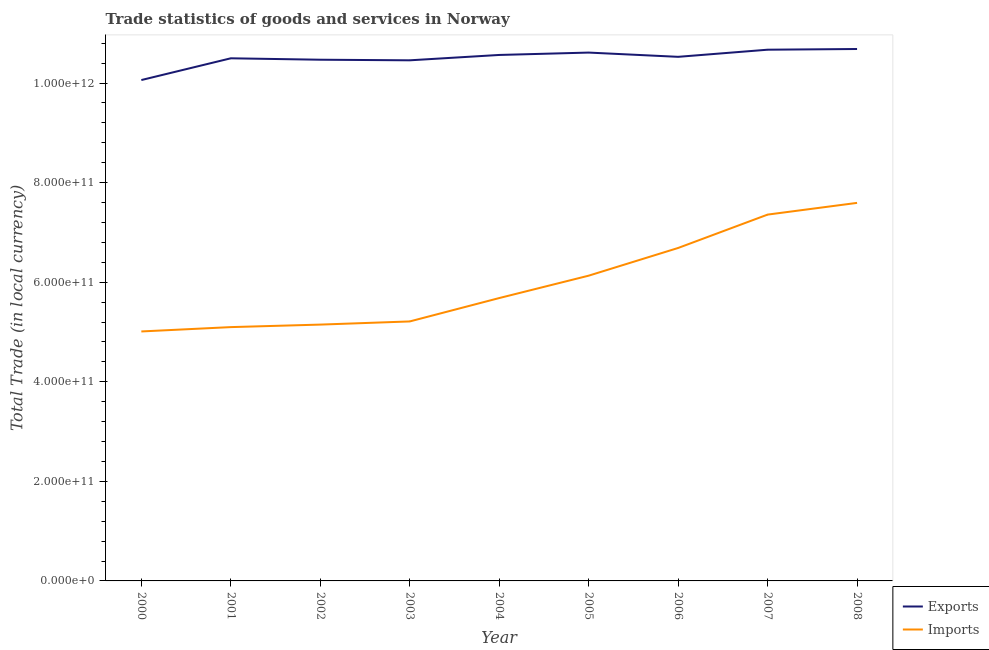Does the line corresponding to export of goods and services intersect with the line corresponding to imports of goods and services?
Keep it short and to the point. No. Is the number of lines equal to the number of legend labels?
Offer a very short reply. Yes. What is the imports of goods and services in 2000?
Ensure brevity in your answer.  5.01e+11. Across all years, what is the maximum export of goods and services?
Keep it short and to the point. 1.07e+12. Across all years, what is the minimum export of goods and services?
Provide a short and direct response. 1.01e+12. In which year was the imports of goods and services maximum?
Provide a short and direct response. 2008. In which year was the export of goods and services minimum?
Give a very brief answer. 2000. What is the total export of goods and services in the graph?
Ensure brevity in your answer.  9.45e+12. What is the difference between the export of goods and services in 2001 and that in 2002?
Provide a succinct answer. 2.86e+09. What is the difference between the export of goods and services in 2003 and the imports of goods and services in 2008?
Offer a very short reply. 2.86e+11. What is the average imports of goods and services per year?
Provide a succinct answer. 5.99e+11. In the year 2006, what is the difference between the imports of goods and services and export of goods and services?
Provide a succinct answer. -3.84e+11. In how many years, is the imports of goods and services greater than 1000000000000 LCU?
Provide a succinct answer. 0. What is the ratio of the export of goods and services in 2003 to that in 2007?
Provide a short and direct response. 0.98. Is the export of goods and services in 2002 less than that in 2006?
Ensure brevity in your answer.  Yes. What is the difference between the highest and the second highest imports of goods and services?
Your answer should be very brief. 2.36e+1. What is the difference between the highest and the lowest export of goods and services?
Keep it short and to the point. 6.24e+1. In how many years, is the imports of goods and services greater than the average imports of goods and services taken over all years?
Your answer should be compact. 4. Is the imports of goods and services strictly greater than the export of goods and services over the years?
Provide a succinct answer. No. How many lines are there?
Your answer should be very brief. 2. How many years are there in the graph?
Make the answer very short. 9. What is the difference between two consecutive major ticks on the Y-axis?
Ensure brevity in your answer.  2.00e+11. Are the values on the major ticks of Y-axis written in scientific E-notation?
Give a very brief answer. Yes. Does the graph contain any zero values?
Give a very brief answer. No. Where does the legend appear in the graph?
Your answer should be very brief. Bottom right. How many legend labels are there?
Ensure brevity in your answer.  2. How are the legend labels stacked?
Your answer should be very brief. Vertical. What is the title of the graph?
Make the answer very short. Trade statistics of goods and services in Norway. What is the label or title of the Y-axis?
Your answer should be very brief. Total Trade (in local currency). What is the Total Trade (in local currency) of Exports in 2000?
Keep it short and to the point. 1.01e+12. What is the Total Trade (in local currency) in Imports in 2000?
Your answer should be compact. 5.01e+11. What is the Total Trade (in local currency) in Exports in 2001?
Your answer should be very brief. 1.05e+12. What is the Total Trade (in local currency) in Imports in 2001?
Ensure brevity in your answer.  5.10e+11. What is the Total Trade (in local currency) in Exports in 2002?
Keep it short and to the point. 1.05e+12. What is the Total Trade (in local currency) of Imports in 2002?
Make the answer very short. 5.15e+11. What is the Total Trade (in local currency) of Exports in 2003?
Your answer should be compact. 1.05e+12. What is the Total Trade (in local currency) of Imports in 2003?
Ensure brevity in your answer.  5.21e+11. What is the Total Trade (in local currency) of Exports in 2004?
Provide a succinct answer. 1.06e+12. What is the Total Trade (in local currency) of Imports in 2004?
Make the answer very short. 5.68e+11. What is the Total Trade (in local currency) in Exports in 2005?
Give a very brief answer. 1.06e+12. What is the Total Trade (in local currency) of Imports in 2005?
Give a very brief answer. 6.13e+11. What is the Total Trade (in local currency) of Exports in 2006?
Your answer should be very brief. 1.05e+12. What is the Total Trade (in local currency) in Imports in 2006?
Keep it short and to the point. 6.69e+11. What is the Total Trade (in local currency) in Exports in 2007?
Your answer should be very brief. 1.07e+12. What is the Total Trade (in local currency) in Imports in 2007?
Your response must be concise. 7.36e+11. What is the Total Trade (in local currency) of Exports in 2008?
Provide a short and direct response. 1.07e+12. What is the Total Trade (in local currency) of Imports in 2008?
Give a very brief answer. 7.59e+11. Across all years, what is the maximum Total Trade (in local currency) of Exports?
Offer a terse response. 1.07e+12. Across all years, what is the maximum Total Trade (in local currency) of Imports?
Your answer should be compact. 7.59e+11. Across all years, what is the minimum Total Trade (in local currency) in Exports?
Give a very brief answer. 1.01e+12. Across all years, what is the minimum Total Trade (in local currency) in Imports?
Offer a very short reply. 5.01e+11. What is the total Total Trade (in local currency) in Exports in the graph?
Provide a succinct answer. 9.45e+12. What is the total Total Trade (in local currency) of Imports in the graph?
Make the answer very short. 5.39e+12. What is the difference between the Total Trade (in local currency) in Exports in 2000 and that in 2001?
Ensure brevity in your answer.  -4.37e+1. What is the difference between the Total Trade (in local currency) in Imports in 2000 and that in 2001?
Your answer should be very brief. -8.71e+09. What is the difference between the Total Trade (in local currency) in Exports in 2000 and that in 2002?
Give a very brief answer. -4.08e+1. What is the difference between the Total Trade (in local currency) in Imports in 2000 and that in 2002?
Your answer should be compact. -1.38e+1. What is the difference between the Total Trade (in local currency) of Exports in 2000 and that in 2003?
Your answer should be very brief. -3.96e+1. What is the difference between the Total Trade (in local currency) of Imports in 2000 and that in 2003?
Your response must be concise. -2.01e+1. What is the difference between the Total Trade (in local currency) in Exports in 2000 and that in 2004?
Offer a terse response. -5.04e+1. What is the difference between the Total Trade (in local currency) in Imports in 2000 and that in 2004?
Make the answer very short. -6.71e+1. What is the difference between the Total Trade (in local currency) in Exports in 2000 and that in 2005?
Your answer should be compact. -5.52e+1. What is the difference between the Total Trade (in local currency) in Imports in 2000 and that in 2005?
Keep it short and to the point. -1.12e+11. What is the difference between the Total Trade (in local currency) of Exports in 2000 and that in 2006?
Offer a terse response. -4.66e+1. What is the difference between the Total Trade (in local currency) of Imports in 2000 and that in 2006?
Keep it short and to the point. -1.68e+11. What is the difference between the Total Trade (in local currency) of Exports in 2000 and that in 2007?
Ensure brevity in your answer.  -6.10e+1. What is the difference between the Total Trade (in local currency) of Imports in 2000 and that in 2007?
Give a very brief answer. -2.35e+11. What is the difference between the Total Trade (in local currency) of Exports in 2000 and that in 2008?
Provide a short and direct response. -6.24e+1. What is the difference between the Total Trade (in local currency) in Imports in 2000 and that in 2008?
Provide a short and direct response. -2.58e+11. What is the difference between the Total Trade (in local currency) of Exports in 2001 and that in 2002?
Your answer should be compact. 2.86e+09. What is the difference between the Total Trade (in local currency) of Imports in 2001 and that in 2002?
Your answer should be very brief. -5.07e+09. What is the difference between the Total Trade (in local currency) of Exports in 2001 and that in 2003?
Make the answer very short. 4.05e+09. What is the difference between the Total Trade (in local currency) of Imports in 2001 and that in 2003?
Ensure brevity in your answer.  -1.14e+1. What is the difference between the Total Trade (in local currency) in Exports in 2001 and that in 2004?
Your response must be concise. -6.71e+09. What is the difference between the Total Trade (in local currency) in Imports in 2001 and that in 2004?
Keep it short and to the point. -5.83e+1. What is the difference between the Total Trade (in local currency) of Exports in 2001 and that in 2005?
Your answer should be compact. -1.15e+1. What is the difference between the Total Trade (in local currency) in Imports in 2001 and that in 2005?
Provide a succinct answer. -1.03e+11. What is the difference between the Total Trade (in local currency) of Exports in 2001 and that in 2006?
Give a very brief answer. -2.94e+09. What is the difference between the Total Trade (in local currency) of Imports in 2001 and that in 2006?
Ensure brevity in your answer.  -1.59e+11. What is the difference between the Total Trade (in local currency) of Exports in 2001 and that in 2007?
Your answer should be compact. -1.73e+1. What is the difference between the Total Trade (in local currency) in Imports in 2001 and that in 2007?
Make the answer very short. -2.26e+11. What is the difference between the Total Trade (in local currency) of Exports in 2001 and that in 2008?
Make the answer very short. -1.87e+1. What is the difference between the Total Trade (in local currency) in Imports in 2001 and that in 2008?
Provide a short and direct response. -2.50e+11. What is the difference between the Total Trade (in local currency) in Exports in 2002 and that in 2003?
Give a very brief answer. 1.19e+09. What is the difference between the Total Trade (in local currency) in Imports in 2002 and that in 2003?
Your answer should be very brief. -6.34e+09. What is the difference between the Total Trade (in local currency) in Exports in 2002 and that in 2004?
Give a very brief answer. -9.57e+09. What is the difference between the Total Trade (in local currency) in Imports in 2002 and that in 2004?
Ensure brevity in your answer.  -5.33e+1. What is the difference between the Total Trade (in local currency) of Exports in 2002 and that in 2005?
Provide a succinct answer. -1.44e+1. What is the difference between the Total Trade (in local currency) in Imports in 2002 and that in 2005?
Your answer should be very brief. -9.83e+1. What is the difference between the Total Trade (in local currency) of Exports in 2002 and that in 2006?
Offer a terse response. -5.80e+09. What is the difference between the Total Trade (in local currency) in Imports in 2002 and that in 2006?
Ensure brevity in your answer.  -1.54e+11. What is the difference between the Total Trade (in local currency) in Exports in 2002 and that in 2007?
Your answer should be compact. -2.01e+1. What is the difference between the Total Trade (in local currency) in Imports in 2002 and that in 2007?
Give a very brief answer. -2.21e+11. What is the difference between the Total Trade (in local currency) of Exports in 2002 and that in 2008?
Provide a succinct answer. -2.15e+1. What is the difference between the Total Trade (in local currency) in Imports in 2002 and that in 2008?
Offer a terse response. -2.44e+11. What is the difference between the Total Trade (in local currency) in Exports in 2003 and that in 2004?
Your answer should be very brief. -1.08e+1. What is the difference between the Total Trade (in local currency) of Imports in 2003 and that in 2004?
Ensure brevity in your answer.  -4.69e+1. What is the difference between the Total Trade (in local currency) of Exports in 2003 and that in 2005?
Your answer should be very brief. -1.55e+1. What is the difference between the Total Trade (in local currency) in Imports in 2003 and that in 2005?
Give a very brief answer. -9.19e+1. What is the difference between the Total Trade (in local currency) of Exports in 2003 and that in 2006?
Give a very brief answer. -6.99e+09. What is the difference between the Total Trade (in local currency) of Imports in 2003 and that in 2006?
Keep it short and to the point. -1.48e+11. What is the difference between the Total Trade (in local currency) in Exports in 2003 and that in 2007?
Ensure brevity in your answer.  -2.13e+1. What is the difference between the Total Trade (in local currency) in Imports in 2003 and that in 2007?
Offer a very short reply. -2.15e+11. What is the difference between the Total Trade (in local currency) of Exports in 2003 and that in 2008?
Ensure brevity in your answer.  -2.27e+1. What is the difference between the Total Trade (in local currency) of Imports in 2003 and that in 2008?
Your answer should be very brief. -2.38e+11. What is the difference between the Total Trade (in local currency) of Exports in 2004 and that in 2005?
Your answer should be compact. -4.78e+09. What is the difference between the Total Trade (in local currency) in Imports in 2004 and that in 2005?
Offer a terse response. -4.50e+1. What is the difference between the Total Trade (in local currency) in Exports in 2004 and that in 2006?
Your answer should be compact. 3.77e+09. What is the difference between the Total Trade (in local currency) of Imports in 2004 and that in 2006?
Provide a short and direct response. -1.01e+11. What is the difference between the Total Trade (in local currency) in Exports in 2004 and that in 2007?
Keep it short and to the point. -1.06e+1. What is the difference between the Total Trade (in local currency) in Imports in 2004 and that in 2007?
Make the answer very short. -1.68e+11. What is the difference between the Total Trade (in local currency) of Exports in 2004 and that in 2008?
Your answer should be compact. -1.20e+1. What is the difference between the Total Trade (in local currency) in Imports in 2004 and that in 2008?
Your response must be concise. -1.91e+11. What is the difference between the Total Trade (in local currency) of Exports in 2005 and that in 2006?
Your answer should be compact. 8.55e+09. What is the difference between the Total Trade (in local currency) in Imports in 2005 and that in 2006?
Give a very brief answer. -5.56e+1. What is the difference between the Total Trade (in local currency) in Exports in 2005 and that in 2007?
Make the answer very short. -5.77e+09. What is the difference between the Total Trade (in local currency) in Imports in 2005 and that in 2007?
Keep it short and to the point. -1.23e+11. What is the difference between the Total Trade (in local currency) of Exports in 2005 and that in 2008?
Make the answer very short. -7.18e+09. What is the difference between the Total Trade (in local currency) of Imports in 2005 and that in 2008?
Give a very brief answer. -1.46e+11. What is the difference between the Total Trade (in local currency) of Exports in 2006 and that in 2007?
Offer a terse response. -1.43e+1. What is the difference between the Total Trade (in local currency) of Imports in 2006 and that in 2007?
Your answer should be very brief. -6.70e+1. What is the difference between the Total Trade (in local currency) in Exports in 2006 and that in 2008?
Give a very brief answer. -1.57e+1. What is the difference between the Total Trade (in local currency) of Imports in 2006 and that in 2008?
Give a very brief answer. -9.06e+1. What is the difference between the Total Trade (in local currency) of Exports in 2007 and that in 2008?
Keep it short and to the point. -1.41e+09. What is the difference between the Total Trade (in local currency) of Imports in 2007 and that in 2008?
Make the answer very short. -2.36e+1. What is the difference between the Total Trade (in local currency) in Exports in 2000 and the Total Trade (in local currency) in Imports in 2001?
Your answer should be compact. 4.96e+11. What is the difference between the Total Trade (in local currency) of Exports in 2000 and the Total Trade (in local currency) of Imports in 2002?
Make the answer very short. 4.91e+11. What is the difference between the Total Trade (in local currency) in Exports in 2000 and the Total Trade (in local currency) in Imports in 2003?
Provide a succinct answer. 4.85e+11. What is the difference between the Total Trade (in local currency) of Exports in 2000 and the Total Trade (in local currency) of Imports in 2004?
Your response must be concise. 4.38e+11. What is the difference between the Total Trade (in local currency) of Exports in 2000 and the Total Trade (in local currency) of Imports in 2005?
Provide a succinct answer. 3.93e+11. What is the difference between the Total Trade (in local currency) of Exports in 2000 and the Total Trade (in local currency) of Imports in 2006?
Provide a short and direct response. 3.37e+11. What is the difference between the Total Trade (in local currency) in Exports in 2000 and the Total Trade (in local currency) in Imports in 2007?
Keep it short and to the point. 2.70e+11. What is the difference between the Total Trade (in local currency) in Exports in 2000 and the Total Trade (in local currency) in Imports in 2008?
Give a very brief answer. 2.47e+11. What is the difference between the Total Trade (in local currency) of Exports in 2001 and the Total Trade (in local currency) of Imports in 2002?
Ensure brevity in your answer.  5.35e+11. What is the difference between the Total Trade (in local currency) in Exports in 2001 and the Total Trade (in local currency) in Imports in 2003?
Your answer should be very brief. 5.29e+11. What is the difference between the Total Trade (in local currency) in Exports in 2001 and the Total Trade (in local currency) in Imports in 2004?
Your answer should be compact. 4.82e+11. What is the difference between the Total Trade (in local currency) of Exports in 2001 and the Total Trade (in local currency) of Imports in 2005?
Provide a short and direct response. 4.37e+11. What is the difference between the Total Trade (in local currency) in Exports in 2001 and the Total Trade (in local currency) in Imports in 2006?
Your response must be concise. 3.81e+11. What is the difference between the Total Trade (in local currency) in Exports in 2001 and the Total Trade (in local currency) in Imports in 2007?
Offer a very short reply. 3.14e+11. What is the difference between the Total Trade (in local currency) of Exports in 2001 and the Total Trade (in local currency) of Imports in 2008?
Provide a short and direct response. 2.90e+11. What is the difference between the Total Trade (in local currency) of Exports in 2002 and the Total Trade (in local currency) of Imports in 2003?
Give a very brief answer. 5.26e+11. What is the difference between the Total Trade (in local currency) of Exports in 2002 and the Total Trade (in local currency) of Imports in 2004?
Keep it short and to the point. 4.79e+11. What is the difference between the Total Trade (in local currency) in Exports in 2002 and the Total Trade (in local currency) in Imports in 2005?
Your answer should be compact. 4.34e+11. What is the difference between the Total Trade (in local currency) in Exports in 2002 and the Total Trade (in local currency) in Imports in 2006?
Your response must be concise. 3.78e+11. What is the difference between the Total Trade (in local currency) of Exports in 2002 and the Total Trade (in local currency) of Imports in 2007?
Make the answer very short. 3.11e+11. What is the difference between the Total Trade (in local currency) of Exports in 2002 and the Total Trade (in local currency) of Imports in 2008?
Ensure brevity in your answer.  2.88e+11. What is the difference between the Total Trade (in local currency) in Exports in 2003 and the Total Trade (in local currency) in Imports in 2004?
Your response must be concise. 4.78e+11. What is the difference between the Total Trade (in local currency) in Exports in 2003 and the Total Trade (in local currency) in Imports in 2005?
Keep it short and to the point. 4.33e+11. What is the difference between the Total Trade (in local currency) of Exports in 2003 and the Total Trade (in local currency) of Imports in 2006?
Offer a terse response. 3.77e+11. What is the difference between the Total Trade (in local currency) of Exports in 2003 and the Total Trade (in local currency) of Imports in 2007?
Your response must be concise. 3.10e+11. What is the difference between the Total Trade (in local currency) of Exports in 2003 and the Total Trade (in local currency) of Imports in 2008?
Keep it short and to the point. 2.86e+11. What is the difference between the Total Trade (in local currency) of Exports in 2004 and the Total Trade (in local currency) of Imports in 2005?
Your answer should be compact. 4.43e+11. What is the difference between the Total Trade (in local currency) of Exports in 2004 and the Total Trade (in local currency) of Imports in 2006?
Offer a terse response. 3.88e+11. What is the difference between the Total Trade (in local currency) of Exports in 2004 and the Total Trade (in local currency) of Imports in 2007?
Ensure brevity in your answer.  3.21e+11. What is the difference between the Total Trade (in local currency) of Exports in 2004 and the Total Trade (in local currency) of Imports in 2008?
Make the answer very short. 2.97e+11. What is the difference between the Total Trade (in local currency) of Exports in 2005 and the Total Trade (in local currency) of Imports in 2006?
Your response must be concise. 3.92e+11. What is the difference between the Total Trade (in local currency) in Exports in 2005 and the Total Trade (in local currency) in Imports in 2007?
Your response must be concise. 3.25e+11. What is the difference between the Total Trade (in local currency) of Exports in 2005 and the Total Trade (in local currency) of Imports in 2008?
Give a very brief answer. 3.02e+11. What is the difference between the Total Trade (in local currency) of Exports in 2006 and the Total Trade (in local currency) of Imports in 2007?
Your answer should be very brief. 3.17e+11. What is the difference between the Total Trade (in local currency) of Exports in 2006 and the Total Trade (in local currency) of Imports in 2008?
Keep it short and to the point. 2.93e+11. What is the difference between the Total Trade (in local currency) in Exports in 2007 and the Total Trade (in local currency) in Imports in 2008?
Provide a short and direct response. 3.08e+11. What is the average Total Trade (in local currency) of Exports per year?
Give a very brief answer. 1.05e+12. What is the average Total Trade (in local currency) of Imports per year?
Make the answer very short. 5.99e+11. In the year 2000, what is the difference between the Total Trade (in local currency) in Exports and Total Trade (in local currency) in Imports?
Offer a very short reply. 5.05e+11. In the year 2001, what is the difference between the Total Trade (in local currency) of Exports and Total Trade (in local currency) of Imports?
Offer a very short reply. 5.40e+11. In the year 2002, what is the difference between the Total Trade (in local currency) of Exports and Total Trade (in local currency) of Imports?
Ensure brevity in your answer.  5.32e+11. In the year 2003, what is the difference between the Total Trade (in local currency) in Exports and Total Trade (in local currency) in Imports?
Your response must be concise. 5.24e+11. In the year 2004, what is the difference between the Total Trade (in local currency) of Exports and Total Trade (in local currency) of Imports?
Offer a terse response. 4.88e+11. In the year 2005, what is the difference between the Total Trade (in local currency) of Exports and Total Trade (in local currency) of Imports?
Provide a short and direct response. 4.48e+11. In the year 2006, what is the difference between the Total Trade (in local currency) in Exports and Total Trade (in local currency) in Imports?
Offer a terse response. 3.84e+11. In the year 2007, what is the difference between the Total Trade (in local currency) in Exports and Total Trade (in local currency) in Imports?
Give a very brief answer. 3.31e+11. In the year 2008, what is the difference between the Total Trade (in local currency) of Exports and Total Trade (in local currency) of Imports?
Make the answer very short. 3.09e+11. What is the ratio of the Total Trade (in local currency) in Exports in 2000 to that in 2001?
Make the answer very short. 0.96. What is the ratio of the Total Trade (in local currency) of Imports in 2000 to that in 2001?
Your answer should be very brief. 0.98. What is the ratio of the Total Trade (in local currency) in Exports in 2000 to that in 2002?
Provide a short and direct response. 0.96. What is the ratio of the Total Trade (in local currency) of Imports in 2000 to that in 2002?
Make the answer very short. 0.97. What is the ratio of the Total Trade (in local currency) in Exports in 2000 to that in 2003?
Keep it short and to the point. 0.96. What is the ratio of the Total Trade (in local currency) of Imports in 2000 to that in 2003?
Your response must be concise. 0.96. What is the ratio of the Total Trade (in local currency) of Exports in 2000 to that in 2004?
Offer a terse response. 0.95. What is the ratio of the Total Trade (in local currency) of Imports in 2000 to that in 2004?
Give a very brief answer. 0.88. What is the ratio of the Total Trade (in local currency) in Exports in 2000 to that in 2005?
Your response must be concise. 0.95. What is the ratio of the Total Trade (in local currency) of Imports in 2000 to that in 2005?
Offer a terse response. 0.82. What is the ratio of the Total Trade (in local currency) of Exports in 2000 to that in 2006?
Your answer should be very brief. 0.96. What is the ratio of the Total Trade (in local currency) of Imports in 2000 to that in 2006?
Your answer should be very brief. 0.75. What is the ratio of the Total Trade (in local currency) in Exports in 2000 to that in 2007?
Your answer should be very brief. 0.94. What is the ratio of the Total Trade (in local currency) of Imports in 2000 to that in 2007?
Offer a very short reply. 0.68. What is the ratio of the Total Trade (in local currency) in Exports in 2000 to that in 2008?
Ensure brevity in your answer.  0.94. What is the ratio of the Total Trade (in local currency) of Imports in 2000 to that in 2008?
Make the answer very short. 0.66. What is the ratio of the Total Trade (in local currency) of Imports in 2001 to that in 2002?
Provide a short and direct response. 0.99. What is the ratio of the Total Trade (in local currency) in Exports in 2001 to that in 2003?
Your answer should be very brief. 1. What is the ratio of the Total Trade (in local currency) in Imports in 2001 to that in 2003?
Keep it short and to the point. 0.98. What is the ratio of the Total Trade (in local currency) in Exports in 2001 to that in 2004?
Your response must be concise. 0.99. What is the ratio of the Total Trade (in local currency) in Imports in 2001 to that in 2004?
Your response must be concise. 0.9. What is the ratio of the Total Trade (in local currency) in Exports in 2001 to that in 2005?
Offer a very short reply. 0.99. What is the ratio of the Total Trade (in local currency) of Imports in 2001 to that in 2005?
Your answer should be very brief. 0.83. What is the ratio of the Total Trade (in local currency) in Imports in 2001 to that in 2006?
Provide a succinct answer. 0.76. What is the ratio of the Total Trade (in local currency) of Exports in 2001 to that in 2007?
Your answer should be compact. 0.98. What is the ratio of the Total Trade (in local currency) of Imports in 2001 to that in 2007?
Offer a terse response. 0.69. What is the ratio of the Total Trade (in local currency) of Exports in 2001 to that in 2008?
Provide a succinct answer. 0.98. What is the ratio of the Total Trade (in local currency) in Imports in 2001 to that in 2008?
Give a very brief answer. 0.67. What is the ratio of the Total Trade (in local currency) of Exports in 2002 to that in 2004?
Make the answer very short. 0.99. What is the ratio of the Total Trade (in local currency) of Imports in 2002 to that in 2004?
Keep it short and to the point. 0.91. What is the ratio of the Total Trade (in local currency) in Exports in 2002 to that in 2005?
Provide a succinct answer. 0.99. What is the ratio of the Total Trade (in local currency) of Imports in 2002 to that in 2005?
Provide a succinct answer. 0.84. What is the ratio of the Total Trade (in local currency) of Exports in 2002 to that in 2006?
Your response must be concise. 0.99. What is the ratio of the Total Trade (in local currency) of Imports in 2002 to that in 2006?
Offer a very short reply. 0.77. What is the ratio of the Total Trade (in local currency) in Exports in 2002 to that in 2007?
Offer a terse response. 0.98. What is the ratio of the Total Trade (in local currency) of Imports in 2002 to that in 2007?
Provide a short and direct response. 0.7. What is the ratio of the Total Trade (in local currency) in Exports in 2002 to that in 2008?
Your response must be concise. 0.98. What is the ratio of the Total Trade (in local currency) in Imports in 2002 to that in 2008?
Your response must be concise. 0.68. What is the ratio of the Total Trade (in local currency) in Imports in 2003 to that in 2004?
Keep it short and to the point. 0.92. What is the ratio of the Total Trade (in local currency) in Exports in 2003 to that in 2005?
Your response must be concise. 0.99. What is the ratio of the Total Trade (in local currency) of Imports in 2003 to that in 2005?
Your answer should be very brief. 0.85. What is the ratio of the Total Trade (in local currency) in Imports in 2003 to that in 2006?
Keep it short and to the point. 0.78. What is the ratio of the Total Trade (in local currency) in Imports in 2003 to that in 2007?
Your answer should be very brief. 0.71. What is the ratio of the Total Trade (in local currency) in Exports in 2003 to that in 2008?
Make the answer very short. 0.98. What is the ratio of the Total Trade (in local currency) in Imports in 2003 to that in 2008?
Your answer should be very brief. 0.69. What is the ratio of the Total Trade (in local currency) of Imports in 2004 to that in 2005?
Provide a short and direct response. 0.93. What is the ratio of the Total Trade (in local currency) of Exports in 2004 to that in 2006?
Provide a succinct answer. 1. What is the ratio of the Total Trade (in local currency) of Imports in 2004 to that in 2006?
Provide a short and direct response. 0.85. What is the ratio of the Total Trade (in local currency) in Exports in 2004 to that in 2007?
Give a very brief answer. 0.99. What is the ratio of the Total Trade (in local currency) in Imports in 2004 to that in 2007?
Keep it short and to the point. 0.77. What is the ratio of the Total Trade (in local currency) in Exports in 2004 to that in 2008?
Provide a succinct answer. 0.99. What is the ratio of the Total Trade (in local currency) in Imports in 2004 to that in 2008?
Your answer should be compact. 0.75. What is the ratio of the Total Trade (in local currency) in Exports in 2005 to that in 2006?
Offer a very short reply. 1.01. What is the ratio of the Total Trade (in local currency) of Imports in 2005 to that in 2006?
Keep it short and to the point. 0.92. What is the ratio of the Total Trade (in local currency) in Imports in 2005 to that in 2007?
Make the answer very short. 0.83. What is the ratio of the Total Trade (in local currency) of Exports in 2005 to that in 2008?
Your answer should be compact. 0.99. What is the ratio of the Total Trade (in local currency) in Imports in 2005 to that in 2008?
Keep it short and to the point. 0.81. What is the ratio of the Total Trade (in local currency) in Exports in 2006 to that in 2007?
Give a very brief answer. 0.99. What is the ratio of the Total Trade (in local currency) of Imports in 2006 to that in 2007?
Offer a terse response. 0.91. What is the ratio of the Total Trade (in local currency) of Imports in 2006 to that in 2008?
Your response must be concise. 0.88. What is the ratio of the Total Trade (in local currency) in Imports in 2007 to that in 2008?
Provide a short and direct response. 0.97. What is the difference between the highest and the second highest Total Trade (in local currency) in Exports?
Give a very brief answer. 1.41e+09. What is the difference between the highest and the second highest Total Trade (in local currency) of Imports?
Give a very brief answer. 2.36e+1. What is the difference between the highest and the lowest Total Trade (in local currency) of Exports?
Your answer should be very brief. 6.24e+1. What is the difference between the highest and the lowest Total Trade (in local currency) in Imports?
Keep it short and to the point. 2.58e+11. 